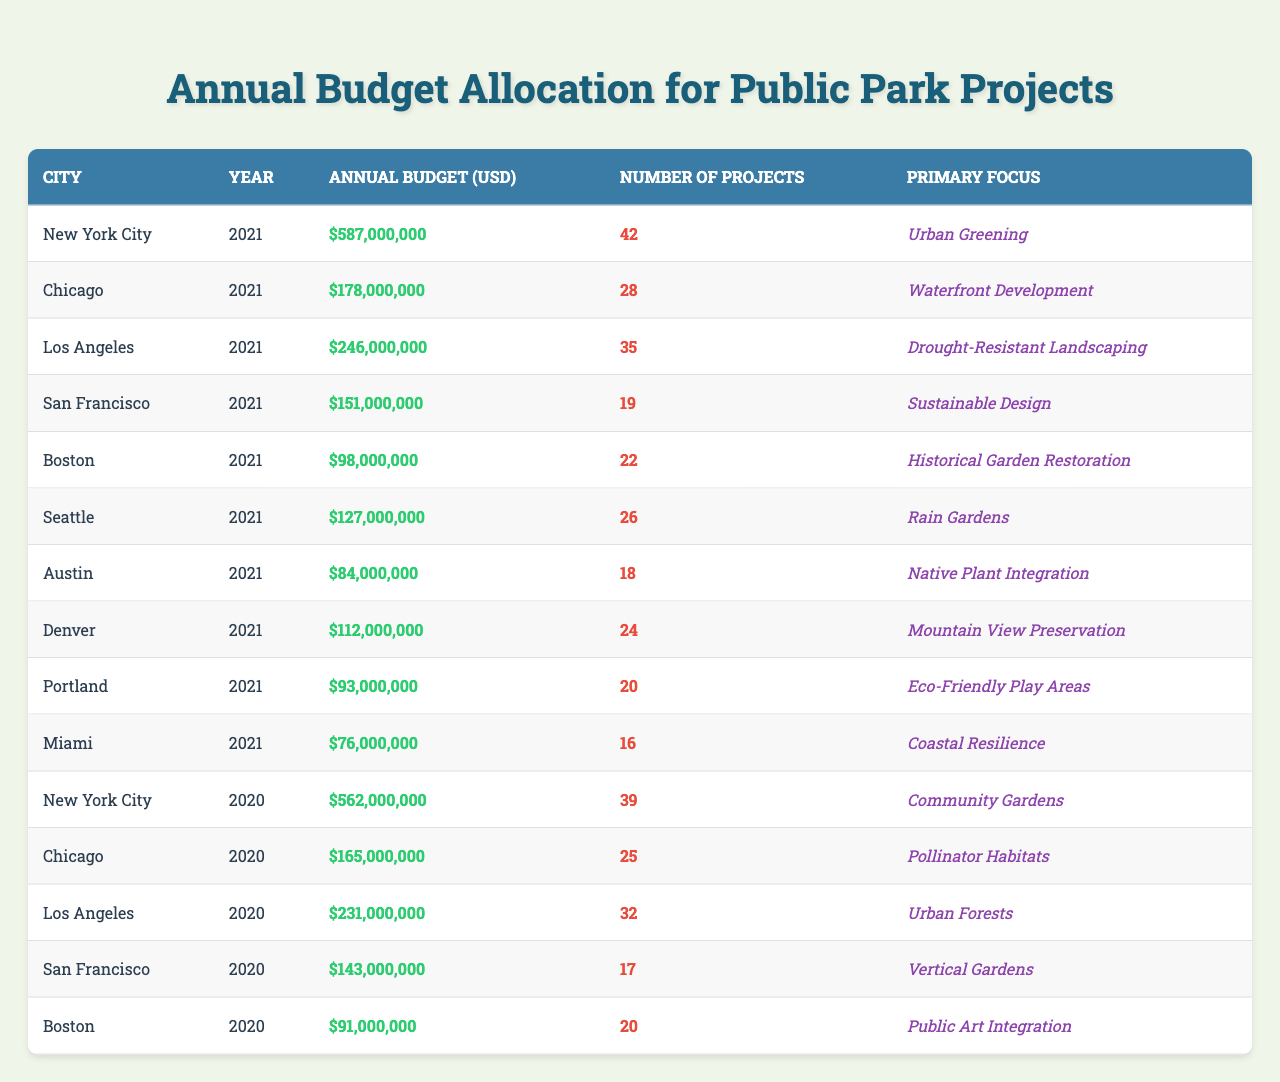What is the annual budget allocation for public park projects in New York City for 2021? The table shows that the annual budget for public park projects in New York City in 2021 is $587,000,000.
Answer: $587,000,000 How many projects were funded in Los Angeles in 2020? According to the table, the number of projects funded in Los Angeles in 2020 was 32.
Answer: 32 Which city had the lowest annual budget in 2021, and what was the amount? By examining the table, we see that Austin had the lowest annual budget in 2021, which was $84,000,000.
Answer: Austin, $84,000,000 What is the difference in annual budget allocation for Chicago between 2020 and 2021? The budget for Chicago in 2020 was $165,000,000 and in 2021 was $178,000,000. The difference is $178,000,000 - $165,000,000 = $13,000,000.
Answer: $13,000,000 Which city focused on "Coastal Resilience" and what was their budget in 2021? The city that focused on "Coastal Resilience" was Miami, which had a budget of $76,000,000 in 2021.
Answer: Miami, $76,000,000 What is the primary focus of the projects financed with the highest budget in 2021? The highest budget in 2021 was for New York City at $587,000,000, and its primary focus was "Urban Greening."
Answer: Urban Greening Calculate the average number of projects funded in the cities listed for 2021. The total number of projects in 2021 is calculated by summing them up: 42 + 28 + 35 + 19 + 22 + 26 + 18 + 24 + 20 + 16 =  240. There are 10 cities, so the average is 240 / 10 = 24.
Answer: 24 Is it true that San Francisco had a higher total budget than Boston in 2021? According to the table, San Francisco's budget was $151,000,000 while Boston's was $98,000,000, indicating that it is true that San Francisco had a higher budget.
Answer: True What was the primary focus of projects for the city that spent $127,000,000 in 2021? The city that spent $127,000,000 in 2021 is Seattle, and its primary focus was "Rain Gardens."
Answer: Rain Gardens Which city had a budget allocation for project development focusing on "Drought-Resistant Landscaping"? Los Angeles had a budget allocation for Drought-Resistant Landscaping, amounting to $246,000,000 in 2021.
Answer: Los Angeles, $246,000,000 